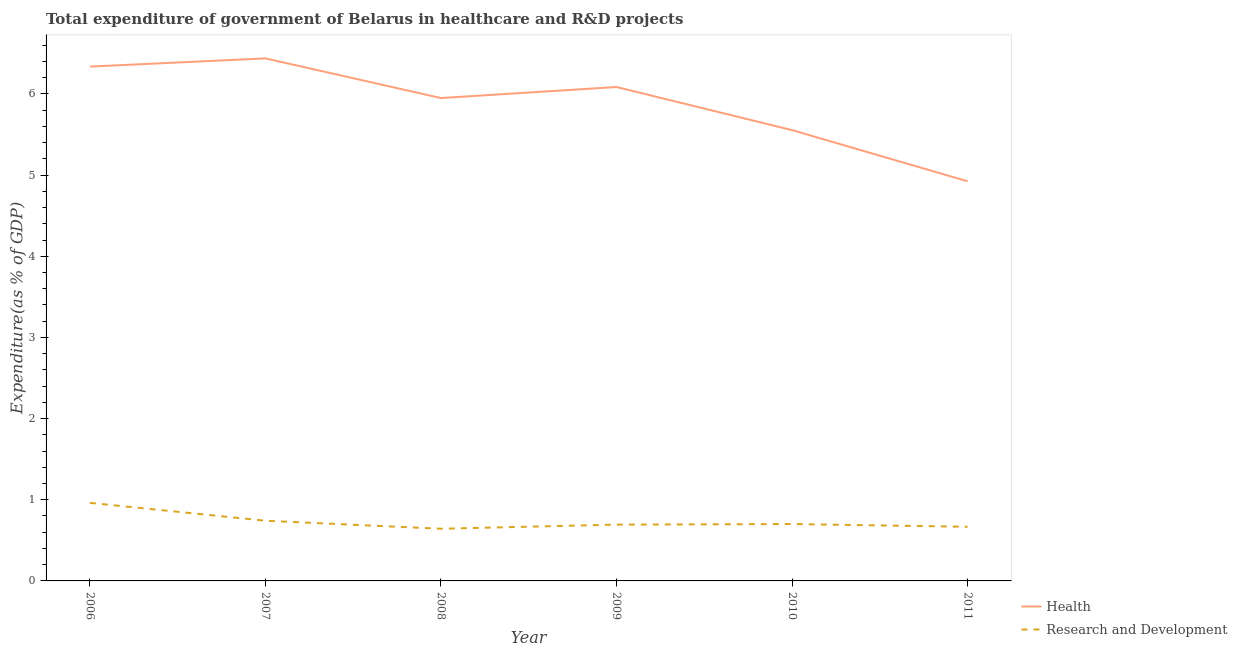How many different coloured lines are there?
Offer a very short reply. 2. Does the line corresponding to expenditure in healthcare intersect with the line corresponding to expenditure in r&d?
Provide a short and direct response. No. Is the number of lines equal to the number of legend labels?
Offer a very short reply. Yes. What is the expenditure in healthcare in 2011?
Provide a short and direct response. 4.92. Across all years, what is the maximum expenditure in healthcare?
Ensure brevity in your answer.  6.44. Across all years, what is the minimum expenditure in r&d?
Provide a short and direct response. 0.64. In which year was the expenditure in healthcare maximum?
Make the answer very short. 2007. What is the total expenditure in r&d in the graph?
Your response must be concise. 4.41. What is the difference between the expenditure in r&d in 2007 and that in 2009?
Provide a short and direct response. 0.05. What is the difference between the expenditure in r&d in 2006 and the expenditure in healthcare in 2010?
Keep it short and to the point. -4.59. What is the average expenditure in r&d per year?
Offer a terse response. 0.73. In the year 2006, what is the difference between the expenditure in healthcare and expenditure in r&d?
Provide a succinct answer. 5.37. What is the ratio of the expenditure in healthcare in 2007 to that in 2011?
Give a very brief answer. 1.31. What is the difference between the highest and the second highest expenditure in r&d?
Offer a terse response. 0.22. What is the difference between the highest and the lowest expenditure in r&d?
Your response must be concise. 0.32. Is the sum of the expenditure in r&d in 2006 and 2010 greater than the maximum expenditure in healthcare across all years?
Provide a succinct answer. No. Is the expenditure in healthcare strictly greater than the expenditure in r&d over the years?
Offer a terse response. Yes. What is the difference between two consecutive major ticks on the Y-axis?
Ensure brevity in your answer.  1. Are the values on the major ticks of Y-axis written in scientific E-notation?
Make the answer very short. No. Does the graph contain grids?
Your response must be concise. No. How are the legend labels stacked?
Give a very brief answer. Vertical. What is the title of the graph?
Your answer should be very brief. Total expenditure of government of Belarus in healthcare and R&D projects. What is the label or title of the X-axis?
Ensure brevity in your answer.  Year. What is the label or title of the Y-axis?
Your answer should be compact. Expenditure(as % of GDP). What is the Expenditure(as % of GDP) of Health in 2006?
Offer a very short reply. 6.34. What is the Expenditure(as % of GDP) of Research and Development in 2006?
Keep it short and to the point. 0.96. What is the Expenditure(as % of GDP) of Health in 2007?
Offer a terse response. 6.44. What is the Expenditure(as % of GDP) of Research and Development in 2007?
Ensure brevity in your answer.  0.74. What is the Expenditure(as % of GDP) in Health in 2008?
Keep it short and to the point. 5.95. What is the Expenditure(as % of GDP) of Research and Development in 2008?
Give a very brief answer. 0.64. What is the Expenditure(as % of GDP) in Health in 2009?
Make the answer very short. 6.09. What is the Expenditure(as % of GDP) in Research and Development in 2009?
Ensure brevity in your answer.  0.69. What is the Expenditure(as % of GDP) of Health in 2010?
Your answer should be compact. 5.55. What is the Expenditure(as % of GDP) in Research and Development in 2010?
Your answer should be compact. 0.7. What is the Expenditure(as % of GDP) in Health in 2011?
Your answer should be compact. 4.92. What is the Expenditure(as % of GDP) of Research and Development in 2011?
Keep it short and to the point. 0.67. Across all years, what is the maximum Expenditure(as % of GDP) of Health?
Make the answer very short. 6.44. Across all years, what is the maximum Expenditure(as % of GDP) of Research and Development?
Provide a succinct answer. 0.96. Across all years, what is the minimum Expenditure(as % of GDP) of Health?
Give a very brief answer. 4.92. Across all years, what is the minimum Expenditure(as % of GDP) in Research and Development?
Keep it short and to the point. 0.64. What is the total Expenditure(as % of GDP) in Health in the graph?
Your response must be concise. 35.29. What is the total Expenditure(as % of GDP) of Research and Development in the graph?
Your answer should be very brief. 4.41. What is the difference between the Expenditure(as % of GDP) in Health in 2006 and that in 2007?
Offer a terse response. -0.1. What is the difference between the Expenditure(as % of GDP) of Research and Development in 2006 and that in 2007?
Your answer should be very brief. 0.22. What is the difference between the Expenditure(as % of GDP) of Health in 2006 and that in 2008?
Provide a succinct answer. 0.39. What is the difference between the Expenditure(as % of GDP) in Research and Development in 2006 and that in 2008?
Ensure brevity in your answer.  0.32. What is the difference between the Expenditure(as % of GDP) of Health in 2006 and that in 2009?
Keep it short and to the point. 0.25. What is the difference between the Expenditure(as % of GDP) of Research and Development in 2006 and that in 2009?
Your answer should be very brief. 0.27. What is the difference between the Expenditure(as % of GDP) in Health in 2006 and that in 2010?
Offer a very short reply. 0.78. What is the difference between the Expenditure(as % of GDP) of Research and Development in 2006 and that in 2010?
Give a very brief answer. 0.26. What is the difference between the Expenditure(as % of GDP) of Health in 2006 and that in 2011?
Ensure brevity in your answer.  1.41. What is the difference between the Expenditure(as % of GDP) of Research and Development in 2006 and that in 2011?
Make the answer very short. 0.29. What is the difference between the Expenditure(as % of GDP) of Health in 2007 and that in 2008?
Make the answer very short. 0.49. What is the difference between the Expenditure(as % of GDP) in Research and Development in 2007 and that in 2008?
Provide a short and direct response. 0.1. What is the difference between the Expenditure(as % of GDP) in Health in 2007 and that in 2009?
Provide a succinct answer. 0.35. What is the difference between the Expenditure(as % of GDP) of Research and Development in 2007 and that in 2009?
Offer a very short reply. 0.05. What is the difference between the Expenditure(as % of GDP) in Health in 2007 and that in 2010?
Provide a succinct answer. 0.88. What is the difference between the Expenditure(as % of GDP) of Research and Development in 2007 and that in 2010?
Your answer should be very brief. 0.04. What is the difference between the Expenditure(as % of GDP) of Health in 2007 and that in 2011?
Your answer should be compact. 1.51. What is the difference between the Expenditure(as % of GDP) of Research and Development in 2007 and that in 2011?
Your response must be concise. 0.07. What is the difference between the Expenditure(as % of GDP) in Health in 2008 and that in 2009?
Your response must be concise. -0.14. What is the difference between the Expenditure(as % of GDP) in Research and Development in 2008 and that in 2009?
Keep it short and to the point. -0.05. What is the difference between the Expenditure(as % of GDP) in Health in 2008 and that in 2010?
Make the answer very short. 0.4. What is the difference between the Expenditure(as % of GDP) of Research and Development in 2008 and that in 2010?
Keep it short and to the point. -0.06. What is the difference between the Expenditure(as % of GDP) in Health in 2008 and that in 2011?
Offer a very short reply. 1.03. What is the difference between the Expenditure(as % of GDP) in Research and Development in 2008 and that in 2011?
Offer a very short reply. -0.02. What is the difference between the Expenditure(as % of GDP) in Health in 2009 and that in 2010?
Your response must be concise. 0.53. What is the difference between the Expenditure(as % of GDP) of Research and Development in 2009 and that in 2010?
Ensure brevity in your answer.  -0.01. What is the difference between the Expenditure(as % of GDP) in Health in 2009 and that in 2011?
Provide a succinct answer. 1.16. What is the difference between the Expenditure(as % of GDP) of Research and Development in 2009 and that in 2011?
Provide a succinct answer. 0.03. What is the difference between the Expenditure(as % of GDP) of Health in 2010 and that in 2011?
Offer a terse response. 0.63. What is the difference between the Expenditure(as % of GDP) in Research and Development in 2010 and that in 2011?
Offer a very short reply. 0.03. What is the difference between the Expenditure(as % of GDP) of Health in 2006 and the Expenditure(as % of GDP) of Research and Development in 2007?
Your response must be concise. 5.6. What is the difference between the Expenditure(as % of GDP) in Health in 2006 and the Expenditure(as % of GDP) in Research and Development in 2008?
Provide a succinct answer. 5.69. What is the difference between the Expenditure(as % of GDP) in Health in 2006 and the Expenditure(as % of GDP) in Research and Development in 2009?
Keep it short and to the point. 5.64. What is the difference between the Expenditure(as % of GDP) in Health in 2006 and the Expenditure(as % of GDP) in Research and Development in 2010?
Your answer should be compact. 5.64. What is the difference between the Expenditure(as % of GDP) in Health in 2006 and the Expenditure(as % of GDP) in Research and Development in 2011?
Ensure brevity in your answer.  5.67. What is the difference between the Expenditure(as % of GDP) in Health in 2007 and the Expenditure(as % of GDP) in Research and Development in 2008?
Provide a succinct answer. 5.79. What is the difference between the Expenditure(as % of GDP) of Health in 2007 and the Expenditure(as % of GDP) of Research and Development in 2009?
Provide a short and direct response. 5.74. What is the difference between the Expenditure(as % of GDP) in Health in 2007 and the Expenditure(as % of GDP) in Research and Development in 2010?
Keep it short and to the point. 5.74. What is the difference between the Expenditure(as % of GDP) of Health in 2007 and the Expenditure(as % of GDP) of Research and Development in 2011?
Provide a short and direct response. 5.77. What is the difference between the Expenditure(as % of GDP) of Health in 2008 and the Expenditure(as % of GDP) of Research and Development in 2009?
Provide a short and direct response. 5.26. What is the difference between the Expenditure(as % of GDP) in Health in 2008 and the Expenditure(as % of GDP) in Research and Development in 2010?
Keep it short and to the point. 5.25. What is the difference between the Expenditure(as % of GDP) of Health in 2008 and the Expenditure(as % of GDP) of Research and Development in 2011?
Make the answer very short. 5.28. What is the difference between the Expenditure(as % of GDP) of Health in 2009 and the Expenditure(as % of GDP) of Research and Development in 2010?
Your answer should be very brief. 5.38. What is the difference between the Expenditure(as % of GDP) of Health in 2009 and the Expenditure(as % of GDP) of Research and Development in 2011?
Make the answer very short. 5.42. What is the difference between the Expenditure(as % of GDP) in Health in 2010 and the Expenditure(as % of GDP) in Research and Development in 2011?
Keep it short and to the point. 4.89. What is the average Expenditure(as % of GDP) in Health per year?
Make the answer very short. 5.88. What is the average Expenditure(as % of GDP) of Research and Development per year?
Ensure brevity in your answer.  0.73. In the year 2006, what is the difference between the Expenditure(as % of GDP) in Health and Expenditure(as % of GDP) in Research and Development?
Keep it short and to the point. 5.37. In the year 2007, what is the difference between the Expenditure(as % of GDP) in Health and Expenditure(as % of GDP) in Research and Development?
Your response must be concise. 5.7. In the year 2008, what is the difference between the Expenditure(as % of GDP) in Health and Expenditure(as % of GDP) in Research and Development?
Provide a short and direct response. 5.31. In the year 2009, what is the difference between the Expenditure(as % of GDP) of Health and Expenditure(as % of GDP) of Research and Development?
Your response must be concise. 5.39. In the year 2010, what is the difference between the Expenditure(as % of GDP) in Health and Expenditure(as % of GDP) in Research and Development?
Provide a succinct answer. 4.85. In the year 2011, what is the difference between the Expenditure(as % of GDP) of Health and Expenditure(as % of GDP) of Research and Development?
Give a very brief answer. 4.26. What is the ratio of the Expenditure(as % of GDP) in Health in 2006 to that in 2007?
Make the answer very short. 0.98. What is the ratio of the Expenditure(as % of GDP) of Research and Development in 2006 to that in 2007?
Provide a short and direct response. 1.3. What is the ratio of the Expenditure(as % of GDP) in Health in 2006 to that in 2008?
Offer a terse response. 1.07. What is the ratio of the Expenditure(as % of GDP) of Research and Development in 2006 to that in 2008?
Ensure brevity in your answer.  1.5. What is the ratio of the Expenditure(as % of GDP) of Health in 2006 to that in 2009?
Provide a succinct answer. 1.04. What is the ratio of the Expenditure(as % of GDP) in Research and Development in 2006 to that in 2009?
Make the answer very short. 1.39. What is the ratio of the Expenditure(as % of GDP) in Health in 2006 to that in 2010?
Offer a terse response. 1.14. What is the ratio of the Expenditure(as % of GDP) in Research and Development in 2006 to that in 2010?
Your response must be concise. 1.37. What is the ratio of the Expenditure(as % of GDP) of Health in 2006 to that in 2011?
Your answer should be compact. 1.29. What is the ratio of the Expenditure(as % of GDP) in Research and Development in 2006 to that in 2011?
Make the answer very short. 1.44. What is the ratio of the Expenditure(as % of GDP) in Health in 2007 to that in 2008?
Your answer should be very brief. 1.08. What is the ratio of the Expenditure(as % of GDP) in Research and Development in 2007 to that in 2008?
Offer a very short reply. 1.15. What is the ratio of the Expenditure(as % of GDP) of Health in 2007 to that in 2009?
Keep it short and to the point. 1.06. What is the ratio of the Expenditure(as % of GDP) in Research and Development in 2007 to that in 2009?
Keep it short and to the point. 1.07. What is the ratio of the Expenditure(as % of GDP) in Health in 2007 to that in 2010?
Your answer should be very brief. 1.16. What is the ratio of the Expenditure(as % of GDP) in Research and Development in 2007 to that in 2010?
Ensure brevity in your answer.  1.06. What is the ratio of the Expenditure(as % of GDP) of Health in 2007 to that in 2011?
Keep it short and to the point. 1.31. What is the ratio of the Expenditure(as % of GDP) in Research and Development in 2007 to that in 2011?
Offer a very short reply. 1.11. What is the ratio of the Expenditure(as % of GDP) in Health in 2008 to that in 2009?
Provide a short and direct response. 0.98. What is the ratio of the Expenditure(as % of GDP) of Research and Development in 2008 to that in 2009?
Provide a short and direct response. 0.93. What is the ratio of the Expenditure(as % of GDP) of Health in 2008 to that in 2010?
Your answer should be compact. 1.07. What is the ratio of the Expenditure(as % of GDP) of Research and Development in 2008 to that in 2010?
Provide a short and direct response. 0.92. What is the ratio of the Expenditure(as % of GDP) of Health in 2008 to that in 2011?
Your answer should be very brief. 1.21. What is the ratio of the Expenditure(as % of GDP) of Research and Development in 2008 to that in 2011?
Offer a very short reply. 0.96. What is the ratio of the Expenditure(as % of GDP) of Health in 2009 to that in 2010?
Keep it short and to the point. 1.1. What is the ratio of the Expenditure(as % of GDP) of Research and Development in 2009 to that in 2010?
Make the answer very short. 0.99. What is the ratio of the Expenditure(as % of GDP) in Health in 2009 to that in 2011?
Your answer should be very brief. 1.24. What is the ratio of the Expenditure(as % of GDP) of Research and Development in 2009 to that in 2011?
Make the answer very short. 1.04. What is the ratio of the Expenditure(as % of GDP) in Health in 2010 to that in 2011?
Your response must be concise. 1.13. What is the ratio of the Expenditure(as % of GDP) in Research and Development in 2010 to that in 2011?
Provide a short and direct response. 1.05. What is the difference between the highest and the second highest Expenditure(as % of GDP) in Health?
Ensure brevity in your answer.  0.1. What is the difference between the highest and the second highest Expenditure(as % of GDP) in Research and Development?
Provide a short and direct response. 0.22. What is the difference between the highest and the lowest Expenditure(as % of GDP) in Health?
Your answer should be very brief. 1.51. What is the difference between the highest and the lowest Expenditure(as % of GDP) in Research and Development?
Ensure brevity in your answer.  0.32. 